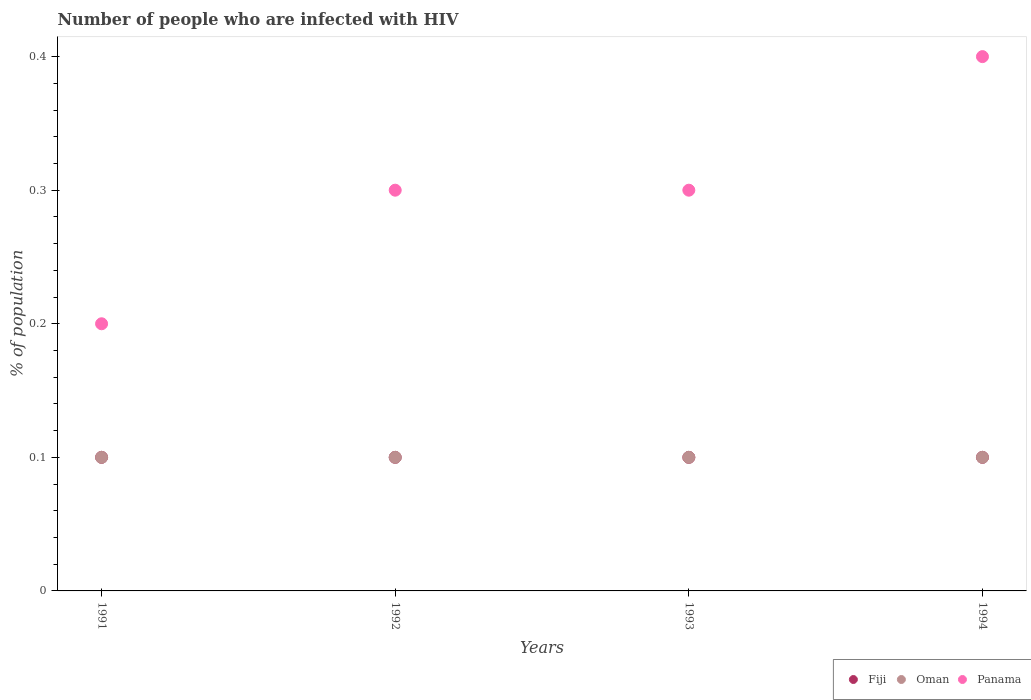Is the number of dotlines equal to the number of legend labels?
Your answer should be compact. Yes. What is the percentage of HIV infected population in in Fiji in 1991?
Provide a succinct answer. 0.1. Across all years, what is the minimum percentage of HIV infected population in in Fiji?
Give a very brief answer. 0.1. In which year was the percentage of HIV infected population in in Fiji minimum?
Make the answer very short. 1991. What is the difference between the percentage of HIV infected population in in Panama in 1993 and that in 1994?
Make the answer very short. -0.1. What is the difference between the percentage of HIV infected population in in Oman in 1993 and the percentage of HIV infected population in in Fiji in 1992?
Your answer should be very brief. 0. In the year 1993, what is the difference between the percentage of HIV infected population in in Panama and percentage of HIV infected population in in Oman?
Make the answer very short. 0.2. In how many years, is the percentage of HIV infected population in in Oman greater than 0.36000000000000004 %?
Provide a short and direct response. 0. What is the ratio of the percentage of HIV infected population in in Fiji in 1991 to that in 1992?
Offer a very short reply. 1. What is the difference between the highest and the second highest percentage of HIV infected population in in Panama?
Your response must be concise. 0.1. Is the sum of the percentage of HIV infected population in in Panama in 1991 and 1992 greater than the maximum percentage of HIV infected population in in Fiji across all years?
Provide a short and direct response. Yes. Is it the case that in every year, the sum of the percentage of HIV infected population in in Fiji and percentage of HIV infected population in in Oman  is greater than the percentage of HIV infected population in in Panama?
Offer a terse response. No. Does the percentage of HIV infected population in in Fiji monotonically increase over the years?
Your answer should be compact. No. Is the percentage of HIV infected population in in Fiji strictly less than the percentage of HIV infected population in in Oman over the years?
Your response must be concise. No. What is the difference between two consecutive major ticks on the Y-axis?
Offer a terse response. 0.1. Are the values on the major ticks of Y-axis written in scientific E-notation?
Your answer should be very brief. No. Does the graph contain grids?
Offer a terse response. No. How many legend labels are there?
Your response must be concise. 3. How are the legend labels stacked?
Make the answer very short. Horizontal. What is the title of the graph?
Your response must be concise. Number of people who are infected with HIV. Does "Djibouti" appear as one of the legend labels in the graph?
Offer a terse response. No. What is the label or title of the Y-axis?
Your response must be concise. % of population. What is the % of population in Panama in 1991?
Your answer should be very brief. 0.2. What is the % of population in Fiji in 1992?
Keep it short and to the point. 0.1. What is the % of population of Oman in 1992?
Offer a very short reply. 0.1. What is the % of population in Panama in 1992?
Offer a terse response. 0.3. What is the % of population in Panama in 1993?
Make the answer very short. 0.3. What is the % of population in Oman in 1994?
Ensure brevity in your answer.  0.1. What is the % of population in Panama in 1994?
Ensure brevity in your answer.  0.4. Across all years, what is the minimum % of population of Panama?
Ensure brevity in your answer.  0.2. What is the total % of population of Oman in the graph?
Provide a succinct answer. 0.4. What is the total % of population in Panama in the graph?
Ensure brevity in your answer.  1.2. What is the difference between the % of population in Panama in 1991 and that in 1993?
Your response must be concise. -0.1. What is the difference between the % of population of Panama in 1992 and that in 1993?
Offer a very short reply. 0. What is the difference between the % of population of Fiji in 1992 and that in 1994?
Provide a succinct answer. 0. What is the difference between the % of population in Panama in 1992 and that in 1994?
Give a very brief answer. -0.1. What is the difference between the % of population in Fiji in 1993 and that in 1994?
Keep it short and to the point. 0. What is the difference between the % of population of Panama in 1993 and that in 1994?
Your response must be concise. -0.1. What is the difference between the % of population of Fiji in 1991 and the % of population of Oman in 1992?
Give a very brief answer. 0. What is the difference between the % of population in Oman in 1991 and the % of population in Panama in 1992?
Your answer should be compact. -0.2. What is the difference between the % of population in Fiji in 1991 and the % of population in Panama in 1993?
Offer a very short reply. -0.2. What is the difference between the % of population of Fiji in 1991 and the % of population of Oman in 1994?
Provide a short and direct response. 0. What is the difference between the % of population of Fiji in 1991 and the % of population of Panama in 1994?
Your response must be concise. -0.3. What is the difference between the % of population in Oman in 1992 and the % of population in Panama in 1993?
Make the answer very short. -0.2. What is the difference between the % of population of Fiji in 1992 and the % of population of Oman in 1994?
Give a very brief answer. 0. What is the difference between the % of population in Fiji in 1993 and the % of population in Oman in 1994?
Provide a succinct answer. 0. What is the difference between the % of population of Oman in 1993 and the % of population of Panama in 1994?
Keep it short and to the point. -0.3. What is the average % of population of Oman per year?
Ensure brevity in your answer.  0.1. What is the average % of population in Panama per year?
Ensure brevity in your answer.  0.3. In the year 1991, what is the difference between the % of population of Fiji and % of population of Oman?
Offer a terse response. 0. In the year 1993, what is the difference between the % of population of Fiji and % of population of Oman?
Give a very brief answer. 0. In the year 1994, what is the difference between the % of population of Oman and % of population of Panama?
Offer a terse response. -0.3. What is the ratio of the % of population of Oman in 1991 to that in 1992?
Make the answer very short. 1. What is the ratio of the % of population in Panama in 1991 to that in 1992?
Provide a short and direct response. 0.67. What is the ratio of the % of population in Panama in 1991 to that in 1993?
Give a very brief answer. 0.67. What is the ratio of the % of population of Fiji in 1991 to that in 1994?
Give a very brief answer. 1. What is the ratio of the % of population of Oman in 1991 to that in 1994?
Your response must be concise. 1. What is the ratio of the % of population in Oman in 1992 to that in 1994?
Provide a succinct answer. 1. What is the ratio of the % of population in Panama in 1992 to that in 1994?
Give a very brief answer. 0.75. What is the ratio of the % of population of Panama in 1993 to that in 1994?
Give a very brief answer. 0.75. What is the difference between the highest and the second highest % of population in Fiji?
Give a very brief answer. 0. What is the difference between the highest and the second highest % of population of Oman?
Provide a short and direct response. 0. What is the difference between the highest and the second highest % of population in Panama?
Provide a short and direct response. 0.1. What is the difference between the highest and the lowest % of population of Panama?
Your answer should be very brief. 0.2. 